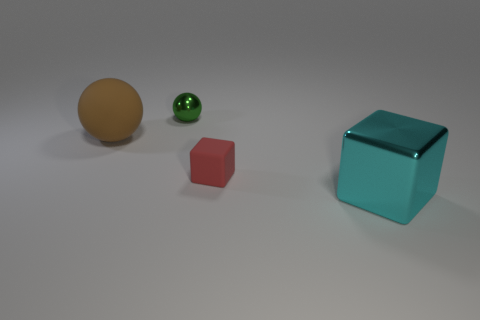Is the small metallic object the same color as the metallic cube?
Keep it short and to the point. No. How many other things are there of the same material as the tiny cube?
Make the answer very short. 1. What number of red blocks are to the left of the cyan object?
Offer a terse response. 1. The green metal object that is the same shape as the big brown thing is what size?
Offer a very short reply. Small. How many cyan objects are either matte balls or large cubes?
Offer a terse response. 1. There is a green shiny object behind the large cyan block; how many rubber things are left of it?
Keep it short and to the point. 1. What number of other things are the same shape as the tiny matte object?
Ensure brevity in your answer.  1. How many big rubber balls are the same color as the tiny matte block?
Offer a very short reply. 0. What is the color of the small thing that is the same material as the cyan block?
Your answer should be compact. Green. Are there any balls that have the same size as the cyan cube?
Provide a short and direct response. Yes. 